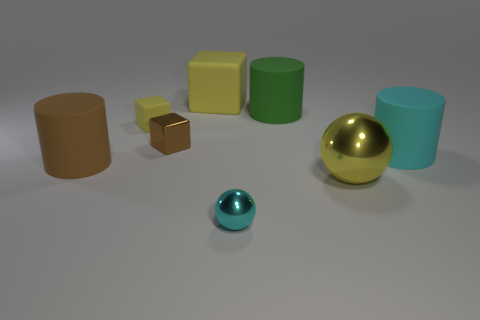Add 1 tiny cyan shiny spheres. How many objects exist? 9 Subtract all cylinders. How many objects are left? 5 Subtract 0 blue blocks. How many objects are left? 8 Subtract all small spheres. Subtract all brown shiny cubes. How many objects are left? 6 Add 8 cyan metal things. How many cyan metal things are left? 9 Add 6 brown rubber balls. How many brown rubber balls exist? 6 